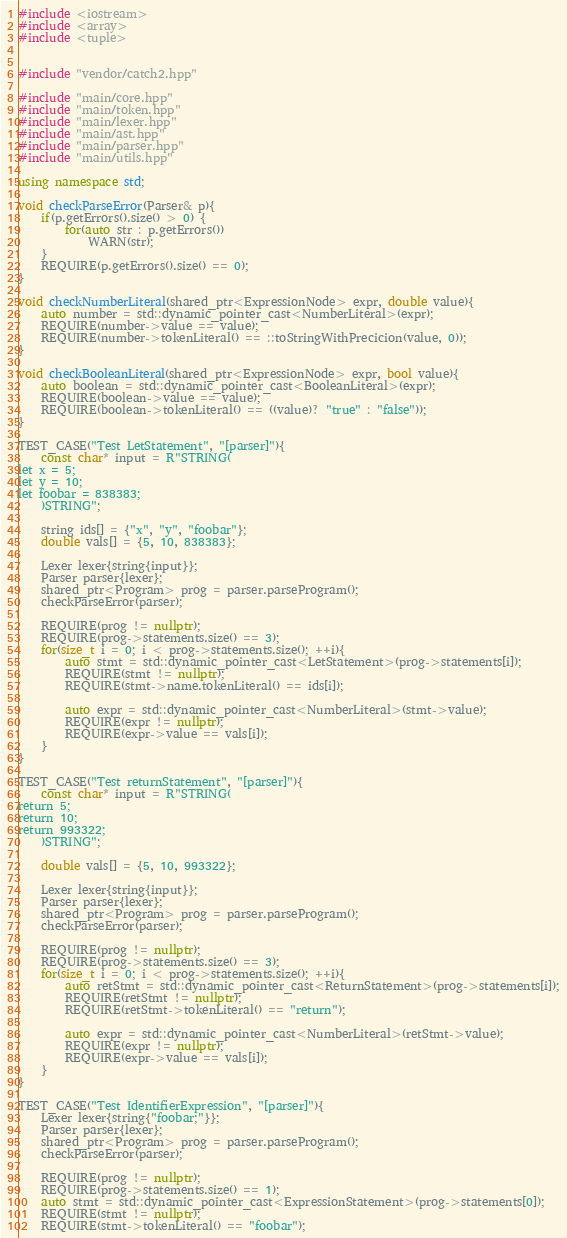<code> <loc_0><loc_0><loc_500><loc_500><_C++_>#include <iostream>
#include <array>
#include <tuple>


#include "vendor/catch2.hpp"

#include "main/core.hpp"
#include "main/token.hpp"
#include "main/lexer.hpp"
#include "main/ast.hpp"
#include "main/parser.hpp"
#include "main/utils.hpp"

using namespace std;

void checkParseError(Parser& p){
    if(p.getErrors().size() > 0) {
        for(auto str : p.getErrors())
            WARN(str);
    }
    REQUIRE(p.getErrors().size() == 0);
}

void checkNumberLiteral(shared_ptr<ExpressionNode> expr, double value){
    auto number = std::dynamic_pointer_cast<NumberLiteral>(expr);
    REQUIRE(number->value == value);
    REQUIRE(number->tokenLiteral() == ::toStringWithPrecicion(value, 0));
}

void checkBooleanLiteral(shared_ptr<ExpressionNode> expr, bool value){
    auto boolean = std::dynamic_pointer_cast<BooleanLiteral>(expr);
    REQUIRE(boolean->value == value);
    REQUIRE(boolean->tokenLiteral() == ((value)? "true" : "false"));
}

TEST_CASE("Test LetStatement", "[parser]"){
    const char* input = R"STRING(
let x = 5;
let y = 10;
let foobar = 838383;
    )STRING";

    string ids[] = {"x", "y", "foobar"};
    double vals[] = {5, 10, 838383};

    Lexer lexer{string{input}};
    Parser parser{lexer};
    shared_ptr<Program> prog = parser.parseProgram();
    checkParseError(parser);

    REQUIRE(prog != nullptr);
    REQUIRE(prog->statements.size() == 3);
    for(size_t i = 0; i < prog->statements.size(); ++i){
        auto stmt = std::dynamic_pointer_cast<LetStatement>(prog->statements[i]);
        REQUIRE(stmt != nullptr);
        REQUIRE(stmt->name.tokenLiteral() == ids[i]);

        auto expr = std::dynamic_pointer_cast<NumberLiteral>(stmt->value);
        REQUIRE(expr != nullptr);
        REQUIRE(expr->value == vals[i]);
    }
}

TEST_CASE("Test returnStatement", "[parser]"){
    const char* input = R"STRING(
return 5;
return 10;
return 993322;
    )STRING";

    double vals[] = {5, 10, 993322};
    
    Lexer lexer{string{input}};
    Parser parser{lexer};
    shared_ptr<Program> prog = parser.parseProgram();
    checkParseError(parser);

    REQUIRE(prog != nullptr);
    REQUIRE(prog->statements.size() == 3);
    for(size_t i = 0; i < prog->statements.size(); ++i){
        auto retStmt = std::dynamic_pointer_cast<ReturnStatement>(prog->statements[i]);
        REQUIRE(retStmt != nullptr);
        REQUIRE(retStmt->tokenLiteral() == "return");

        auto expr = std::dynamic_pointer_cast<NumberLiteral>(retStmt->value);
        REQUIRE(expr != nullptr);
        REQUIRE(expr->value == vals[i]);
    }
}

TEST_CASE("Test IdentifierExpression", "[parser]"){
    Lexer lexer{string{"foobar;"}};
    Parser parser{lexer};
    shared_ptr<Program> prog = parser.parseProgram();
    checkParseError(parser);

    REQUIRE(prog != nullptr);
    REQUIRE(prog->statements.size() == 1);
    auto stmt = std::dynamic_pointer_cast<ExpressionStatement>(prog->statements[0]);
    REQUIRE(stmt != nullptr);
    REQUIRE(stmt->tokenLiteral() == "foobar");</code> 